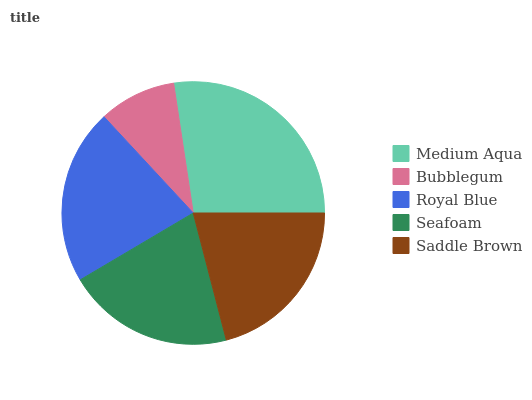Is Bubblegum the minimum?
Answer yes or no. Yes. Is Medium Aqua the maximum?
Answer yes or no. Yes. Is Royal Blue the minimum?
Answer yes or no. No. Is Royal Blue the maximum?
Answer yes or no. No. Is Royal Blue greater than Bubblegum?
Answer yes or no. Yes. Is Bubblegum less than Royal Blue?
Answer yes or no. Yes. Is Bubblegum greater than Royal Blue?
Answer yes or no. No. Is Royal Blue less than Bubblegum?
Answer yes or no. No. Is Saddle Brown the high median?
Answer yes or no. Yes. Is Saddle Brown the low median?
Answer yes or no. Yes. Is Royal Blue the high median?
Answer yes or no. No. Is Medium Aqua the low median?
Answer yes or no. No. 